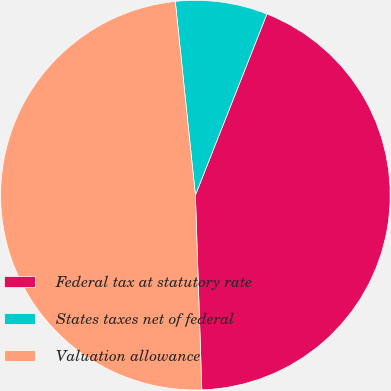Convert chart to OTSL. <chart><loc_0><loc_0><loc_500><loc_500><pie_chart><fcel>Federal tax at statutory rate<fcel>States taxes net of federal<fcel>Valuation allowance<nl><fcel>43.49%<fcel>7.63%<fcel>48.88%<nl></chart> 